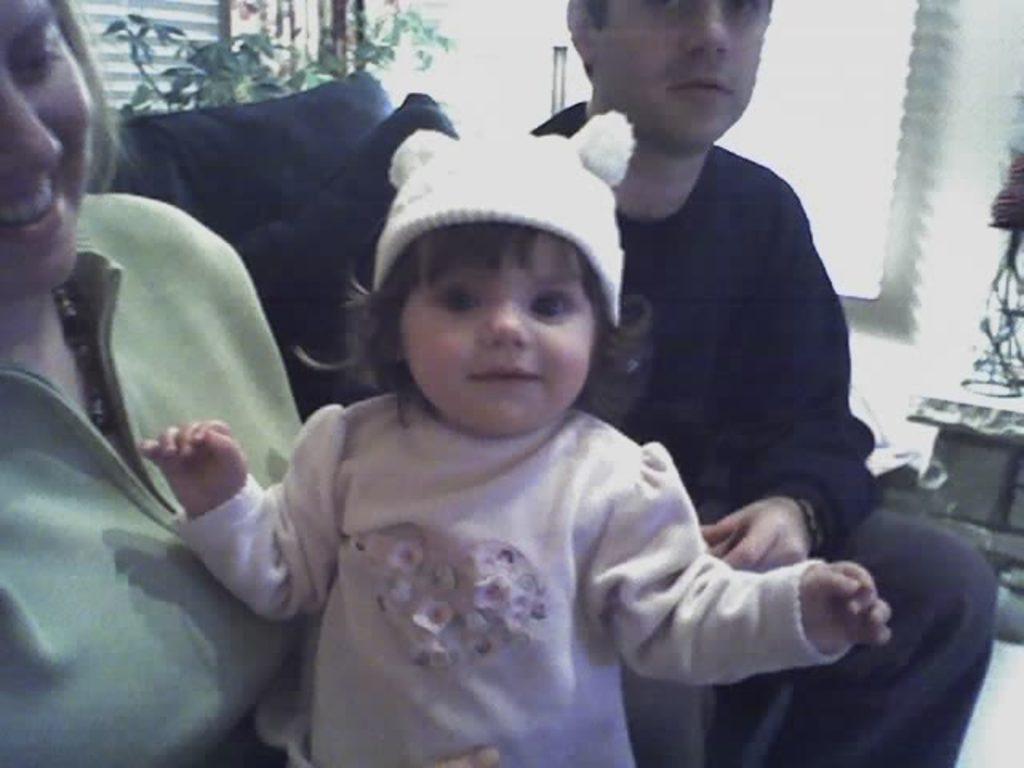Describe this image in one or two sentences. In the left side a beautiful woman is sitting, in the middle a little baby is laughing, this baby wore a sweater. In the right side a man is sitting. 